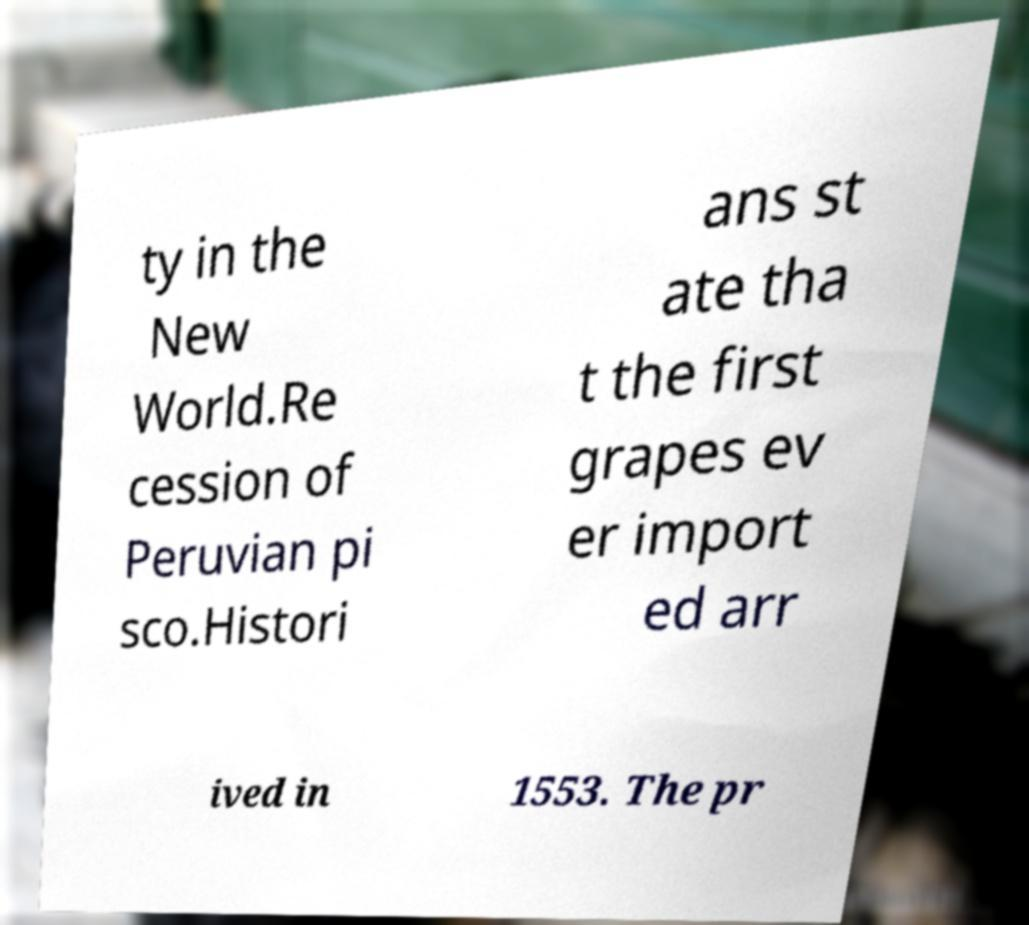Could you assist in decoding the text presented in this image and type it out clearly? ty in the New World.Re cession of Peruvian pi sco.Histori ans st ate tha t the first grapes ev er import ed arr ived in 1553. The pr 